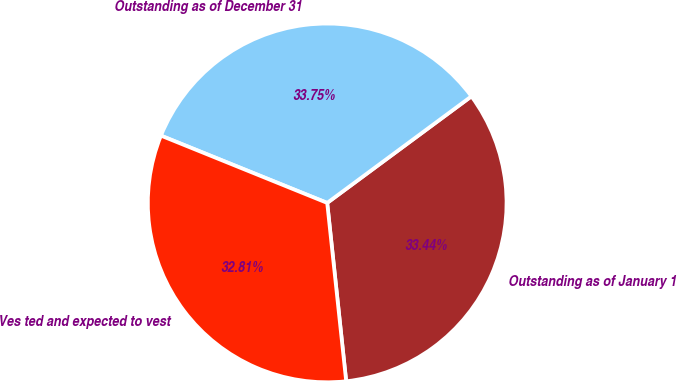Convert chart to OTSL. <chart><loc_0><loc_0><loc_500><loc_500><pie_chart><fcel>Outstanding as of January 1<fcel>Outstanding as of December 31<fcel>Ves ted and expected to vest<nl><fcel>33.44%<fcel>33.75%<fcel>32.81%<nl></chart> 